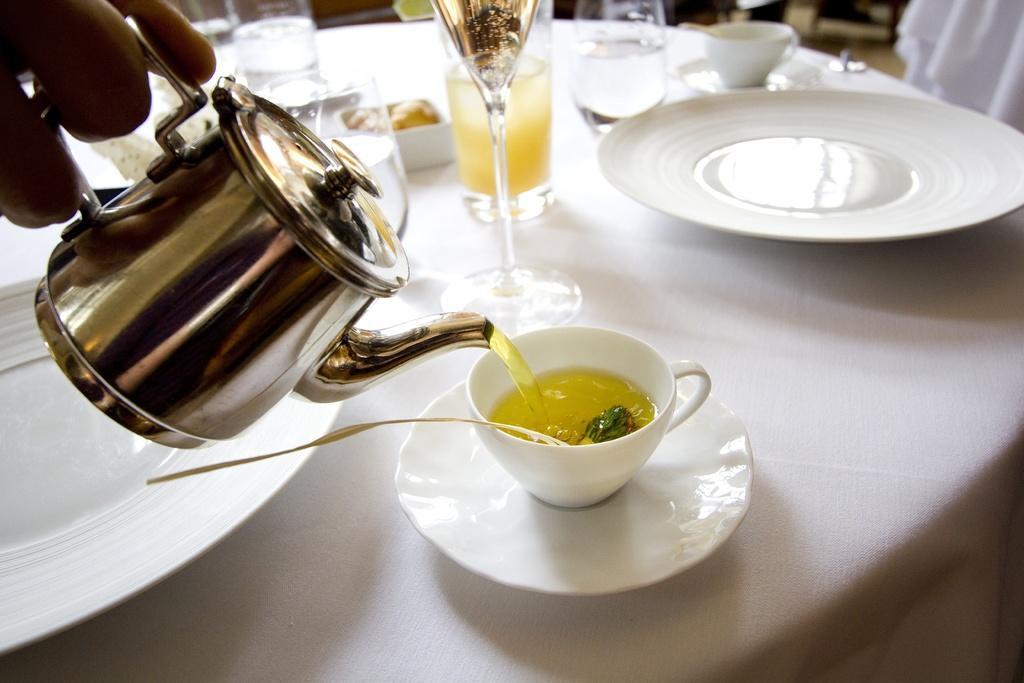Please provide a concise description of this image. In this image there is a table. On the table there are plates,cups,glasses. From the left side on e person is pouring some tea on the cup from the jug. 